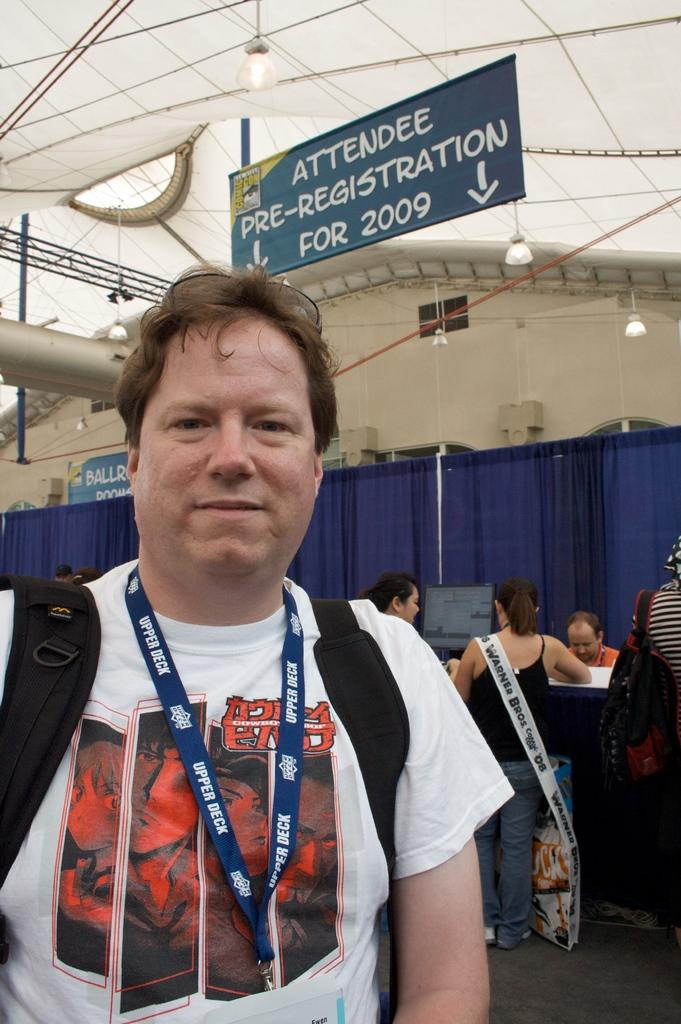<image>
Describe the image concisely. A man stands infront of  sign directing atteedees for pre-registration. 